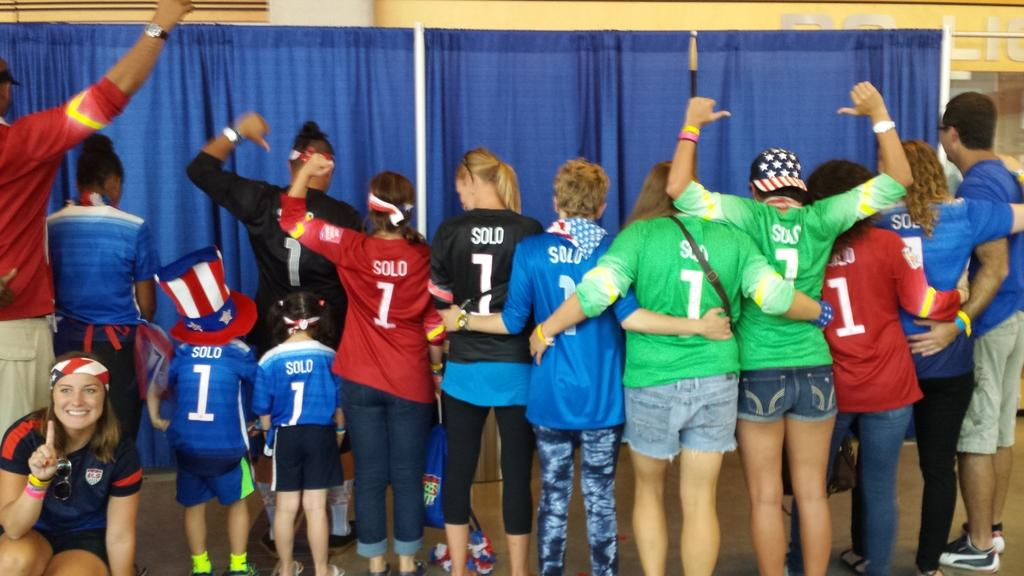<image>
Describe the image concisely. A group of girls wearing jerseys of Solo and the number 1 pose together. 